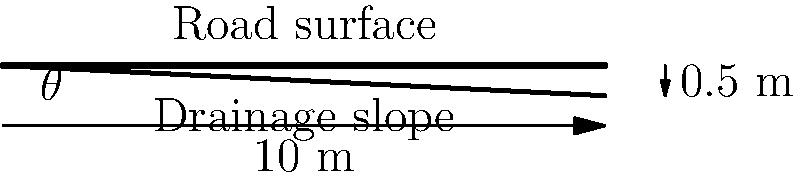Given the cross-sectional diagram of a road, calculate the optimal slope angle $\theta$ for proper drainage. The road width is 10 meters, and the height difference between the center and the edge is 0.5 meters. Round your answer to the nearest tenth of a degree. To determine the optimal slope angle for road drainage, we'll follow these steps:

1. Identify the given information:
   - Road width = 10 meters
   - Height difference = 0.5 meters

2. Recall the formula for slope:
   $\text{Slope} = \frac{\text{Rise}}{\text{Run}}$

3. In this case:
   - Rise = 0.5 meters
   - Run = 5 meters (half of the road width)

4. Calculate the slope:
   $\text{Slope} = \frac{0.5 \text{ m}}{5 \text{ m}} = 0.1$

5. To find the angle $\theta$, we need to use the inverse tangent function:
   $\theta = \tan^{-1}(\text{Slope})$

6. Calculate the angle:
   $\theta = \tan^{-1}(0.1) \approx 5.71°$

7. Round to the nearest tenth of a degree:
   $\theta \approx 5.7°$

Therefore, the optimal slope angle for proper road drainage is approximately 5.7°.
Answer: 5.7° 